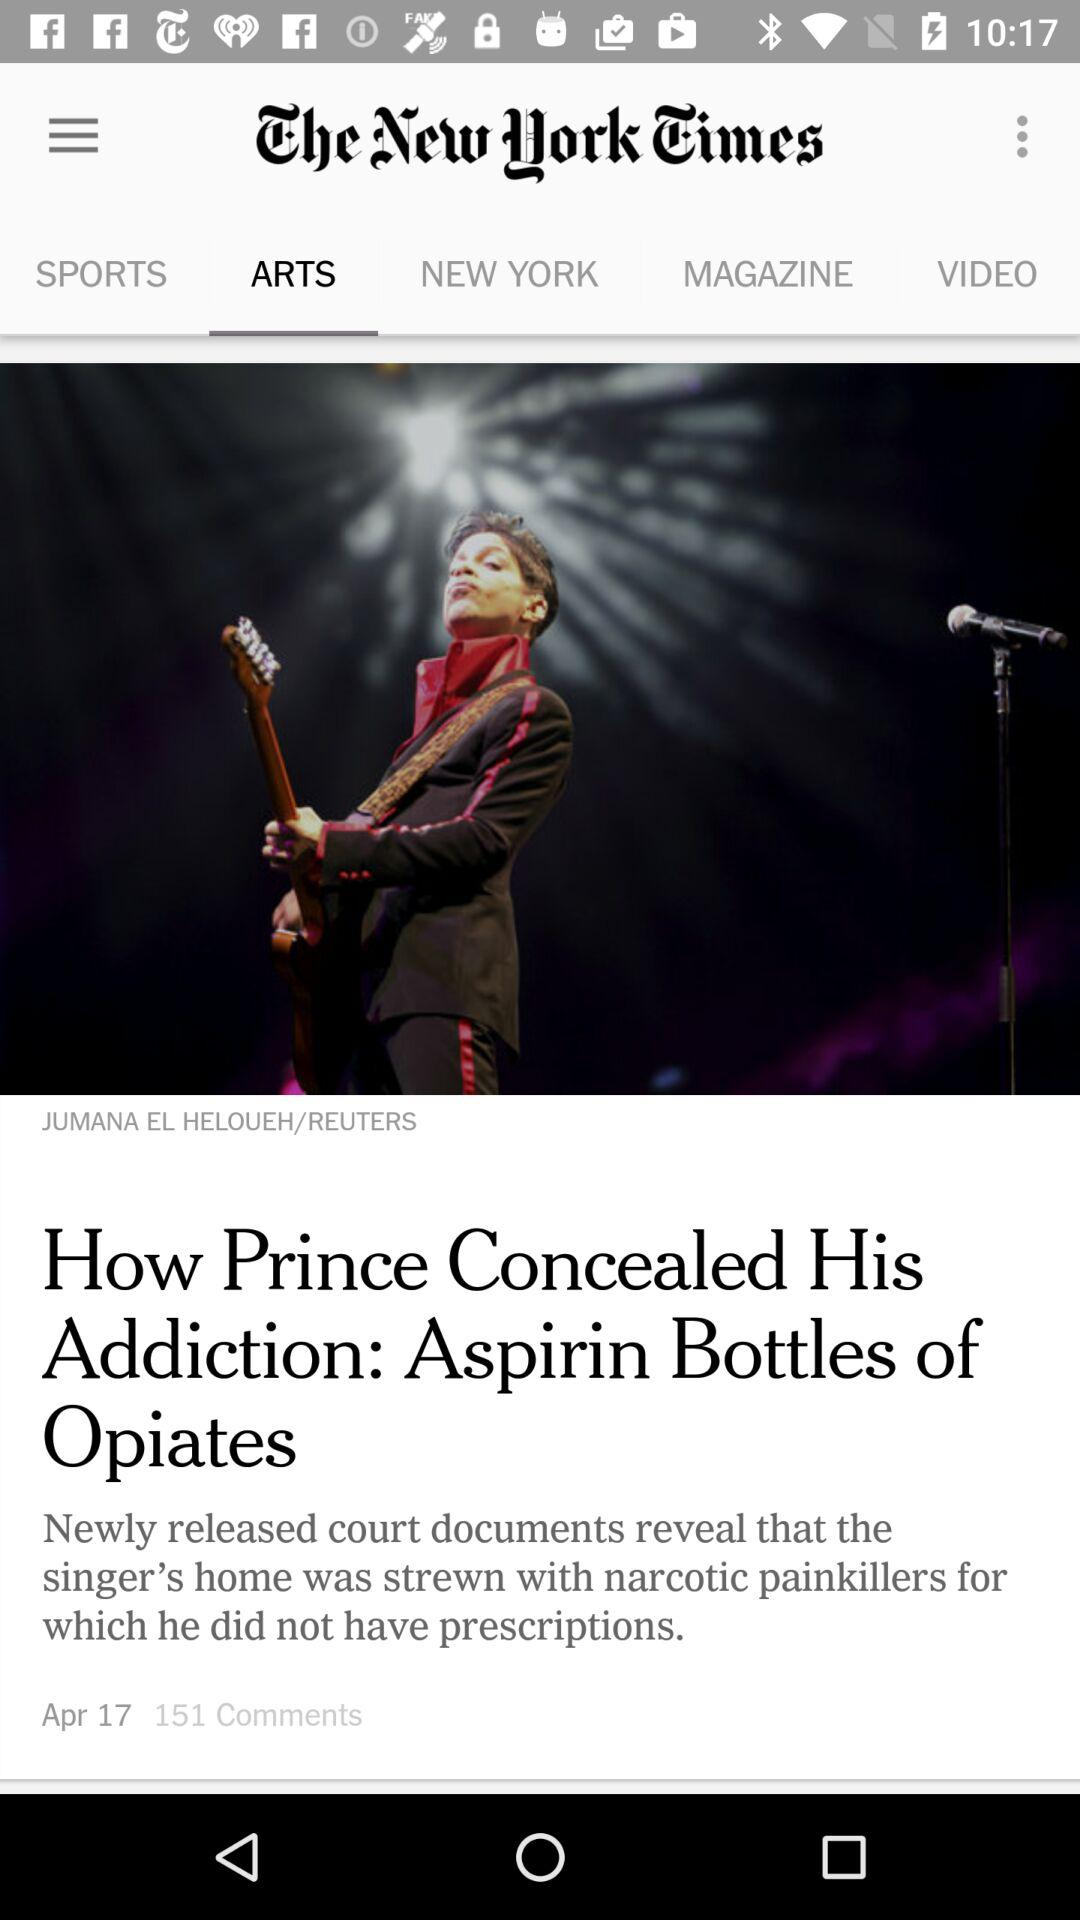When was "How Prince Concealed His Addiction" posted? "How Prince Concealed His Addiction" was posted on April 17. 